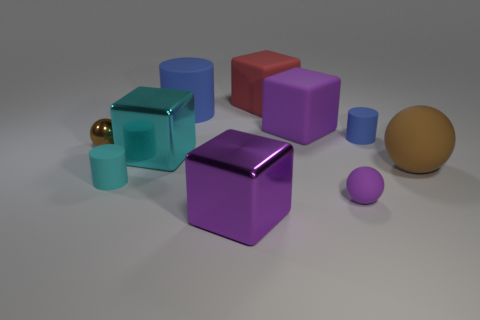Can you describe the shapes seen in the image? Certainly, the image features geometric shapes: cubes, a sphere, and what appears to be a rounded cylinder. The cubes have distinct edges and flat faces, while the sphere and cylinder exhibit smooth, curved surfaces. 